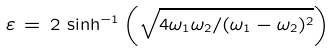<formula> <loc_0><loc_0><loc_500><loc_500>\varepsilon \, = \, 2 \, \sinh ^ { - 1 } \left ( \sqrt { 4 \omega _ { 1 } \omega _ { 2 } / ( \omega _ { 1 } - \omega _ { 2 } ) ^ { 2 } } \right )</formula> 